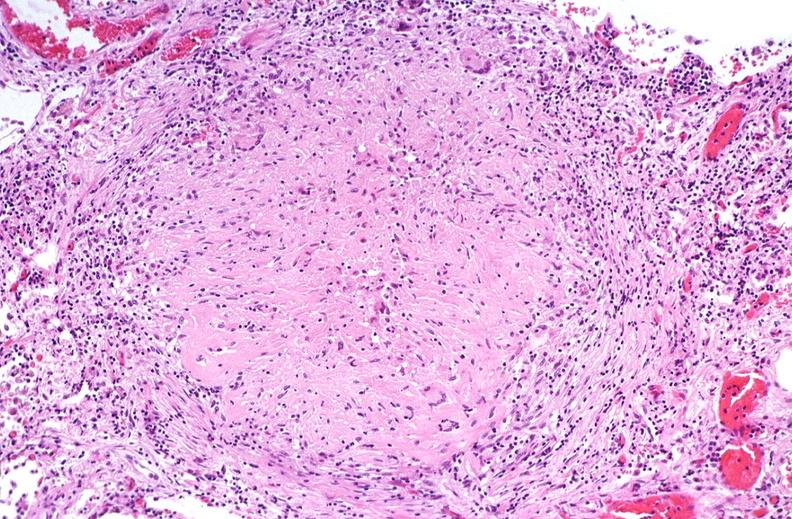s ulcer due to tube present?
Answer the question using a single word or phrase. No 